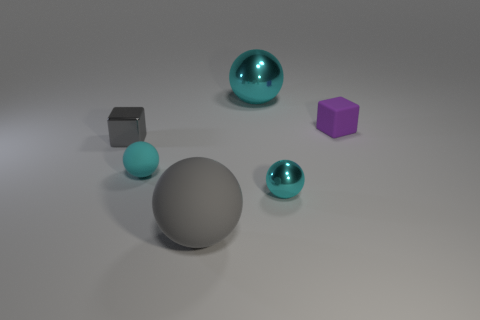The sphere that is the same color as the metallic cube is what size?
Offer a terse response. Large. There is a big sphere in front of the rubber cube; is it the same color as the metal sphere that is behind the small gray cube?
Ensure brevity in your answer.  No. What number of objects are either cyan matte balls or big brown shiny objects?
Make the answer very short. 1. What number of other things are there of the same shape as the tiny cyan rubber object?
Provide a short and direct response. 3. Is the material of the big cyan object that is to the right of the tiny cyan rubber ball the same as the small cube that is to the right of the metallic block?
Give a very brief answer. No. There is a rubber object that is both behind the gray sphere and to the left of the purple rubber cube; what shape is it?
Offer a terse response. Sphere. Are there any other things that have the same material as the purple thing?
Ensure brevity in your answer.  Yes. There is a cyan thing that is both to the left of the small cyan metal thing and in front of the small gray shiny cube; what material is it?
Offer a very short reply. Rubber. What is the shape of the tiny gray thing that is made of the same material as the large cyan object?
Provide a short and direct response. Cube. Is there anything else that has the same color as the large rubber object?
Make the answer very short. Yes. 